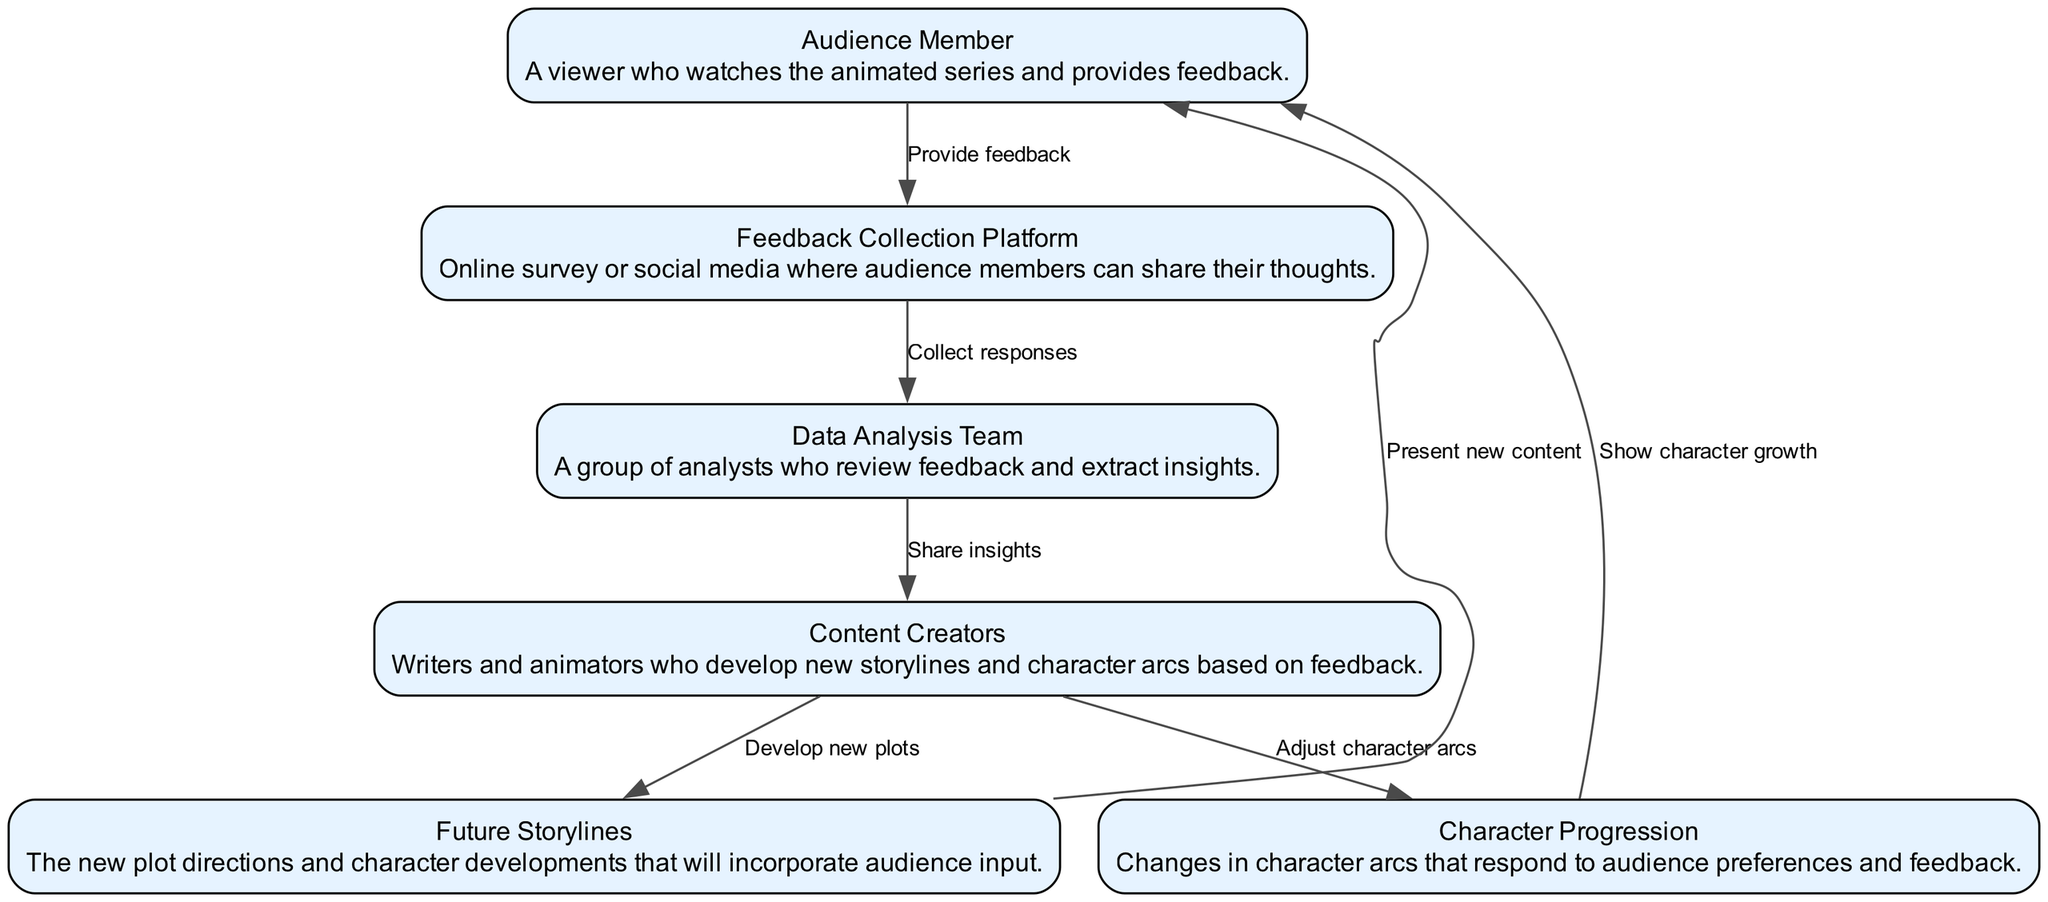What is the first action taken by the Audience Member? The diagram indicates that the first action is providing feedback to the feedback collection platform.
Answer: Provide feedback How many nodes are present in the diagram? Counting the circles indicating participants in the sequence, there are six nodes: Audience Member, Feedback Collection Platform, Data Analysis Team, Content Creators, Future Storylines, and Character Progression.
Answer: Six Which node receives responses from the Feedback Collection Platform? The arrow from the Feedback Collection Platform points to the Data Analysis Team, indicating that this team collects responses next.
Answer: Data Analysis Team What do Content Creators develop based on feedback? The diagram shows that Content Creators develop new plots as one of their actions following insights received from the Data Analysis Team.
Answer: New plots What feedback action is shown going back to the Audience Member after character arcs are adjusted? The diagram illustrates that after adjustments to character arcs, the Content Creators show character growth to the Audience Member.
Answer: Show character growth Which two nodes are connected through the action "Share insights"? The arrow labeled "Share insights" connects the Data Analysis Team with the Content Creators, indicating that insights are shared between these two nodes.
Answer: Data Analysis Team and Content Creators What is the outcome of the new plots developed by Content Creators? After the Content Creators develop new plots, the diagram shows they present new content, leading back to the Audience Member.
Answer: Present new content Explain how feedback influences future storylines according to the diagram. The Audience Member first provides feedback that is collected by the Feedback Collection Platform. This feedback is then analyzed by the Data Analysis Team, which shares insights with Content Creators, who subsequently develop new plots and character arcs based on this feedback. Thus, feedback directly shapes future storylines.
Answer: Feedback shapes future storylines 